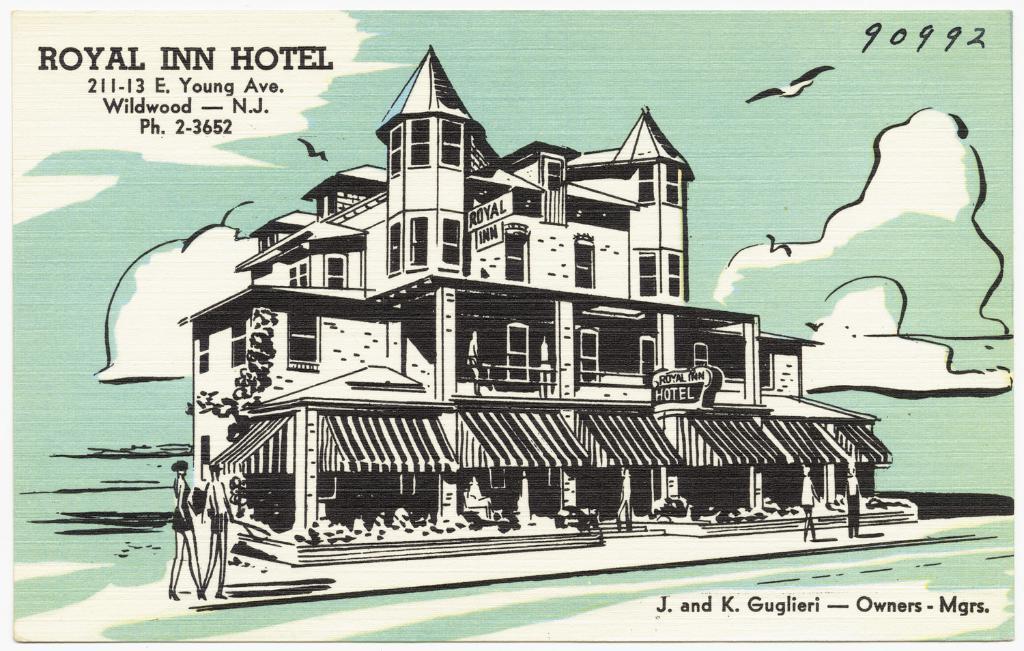In one or two sentences, can you explain what this image depicts? In this image we can see one painting poster. There are some clouds, birds, some text and numbers are in the poster, one big hotel building and some people are in front of the hotel. 